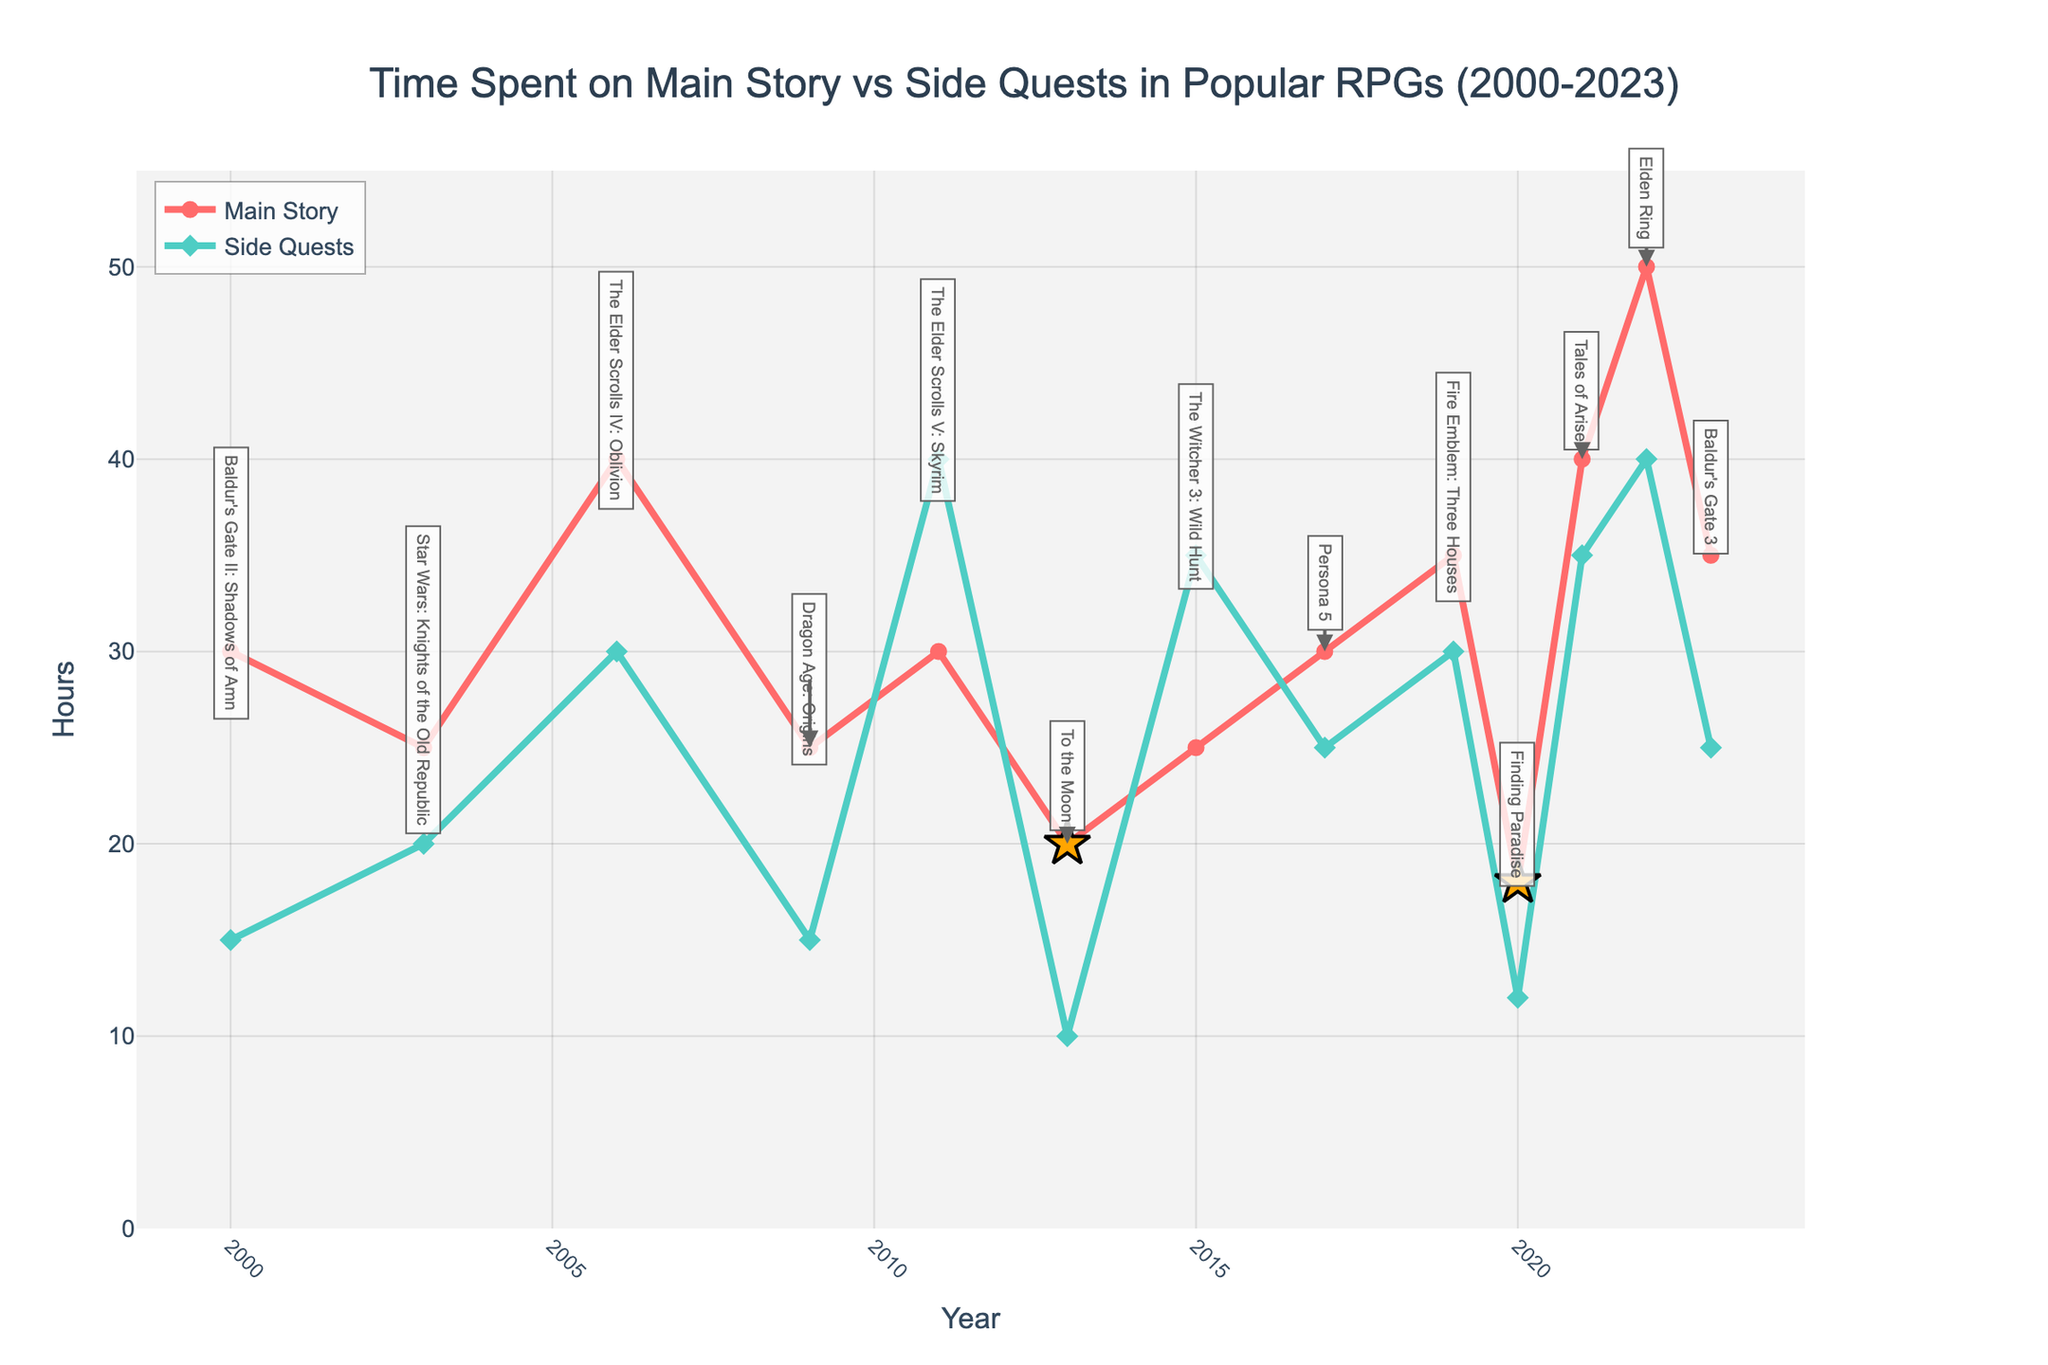Which game has the highest total time spent (main story plus side quests)? To find the highest total time spent, sum the main story and side quests for each game. The game with the highest sum is "Elden Ring" with 50 (main story) + 40 (side quests) = 90 hours.
Answer: Elden Ring In which year does the difference between main story and side quests hours become the greatest? Calculate the absolute difference between main story and side quests for each year. The greatest difference is in 2011 for "The Elder Scrolls V: Skyrim" with a difference of 40 - 30 = 10 hours.
Answer: 2011 Which game has more side quest hours than main story hours? Look for games where the side quest hours exceed main story hours. "The Elder Scrolls V: Skyrim" (2011) and "The Witcher 3: Wild Hunt" (2015) both have more side quest hours (40 and 35 respectively) than main story hours (30 and 25 respectively).
Answer: The Elder Scrolls V: Skyrim, The Witcher 3: Wild Hunt How has the average time spent on main stories evolved from 2000 to 2023? Sum the main story hours for all the years and divide by the number of years: (30+25+40+25+30+20+25+30+35+18+40+50+35) / 13 ≈ 30.23 hours. The average fluctuates around this mean but rises notably in recent years.
Answer: 30.23 hours Which game from the To the Moon series has more total playtime? "To the Moon" in 2013 and "Finding Paradise" in 2020 are the games to compare. "To the Moon" has 30 (Main Story) + 10 (Side Quests) = 30 hours; "Finding Paradise" has 18 (Main Story) + 12 (Side Quests) = 30 hours. They have equal total playtime.
Answer: Both have equal playtime When comparing "The Elder Scrolls IV: Oblivion" and "The Elder Scrolls V: Skyrim," which has a greater sum of main story and side quest hours? Sum the hours for each game: "The Elder Scrolls IV: Oblivion" (40+30) = 70 hours, "The Elder Scrolls V: Skyrim" (30+40) = 70 hours. Both have the same sum of hours.
Answer: Both are equal Which year shows the lowest time spent on main story games? Observing the line for the main story, the lowest point is in 2020 for "Finding Paradise" with only 18 hours.
Answer: 2020 What are the visual differences in the markers for "To the Moon" and "Finding Paradise" compared to other games? The markers for "To the Moon" and "Finding Paradise" are notable for their star shape and larger size compared to the circles and diamonds of other games.
Answer: Star shape, larger size 